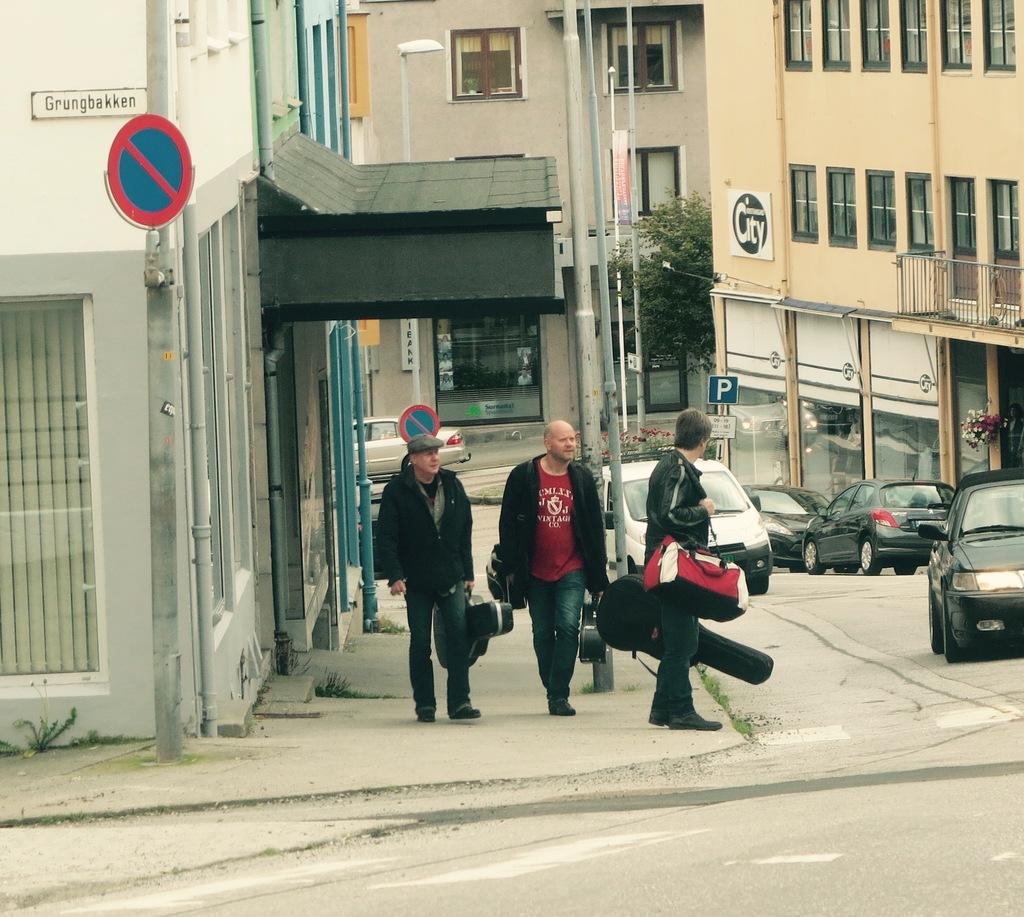What instrument is the man on the right likely carrying?
Keep it short and to the point. Answering does not require reading text in the image. What is the street name?
Ensure brevity in your answer.  Grungbakken. 